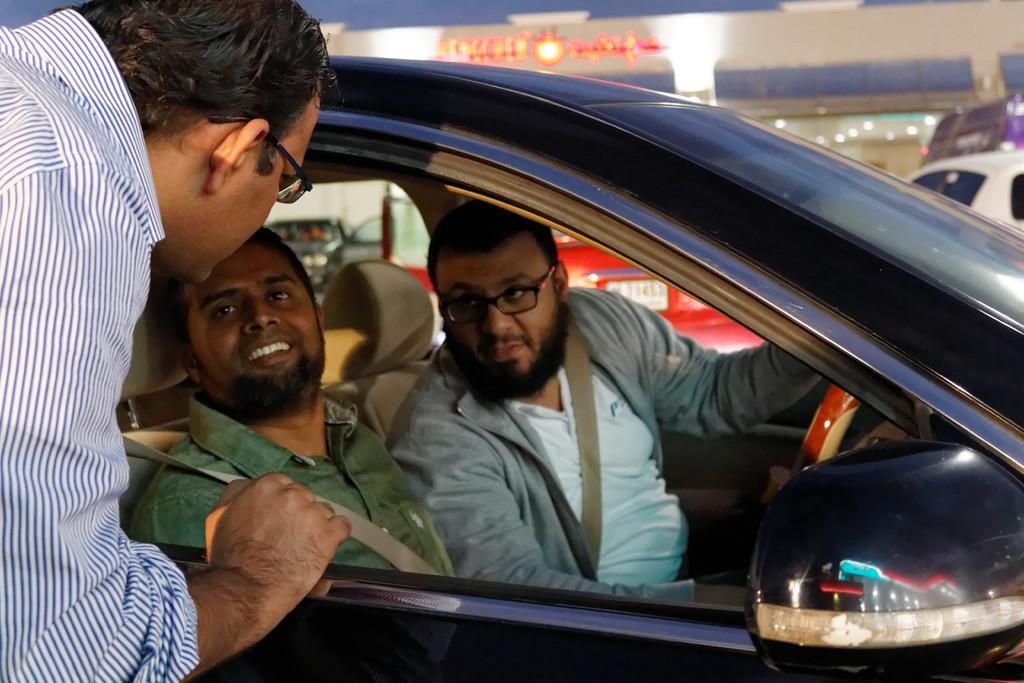Could you give a brief overview of what you see in this image? In this image I see 2 men who are sitting in the car and there is a man over here. 